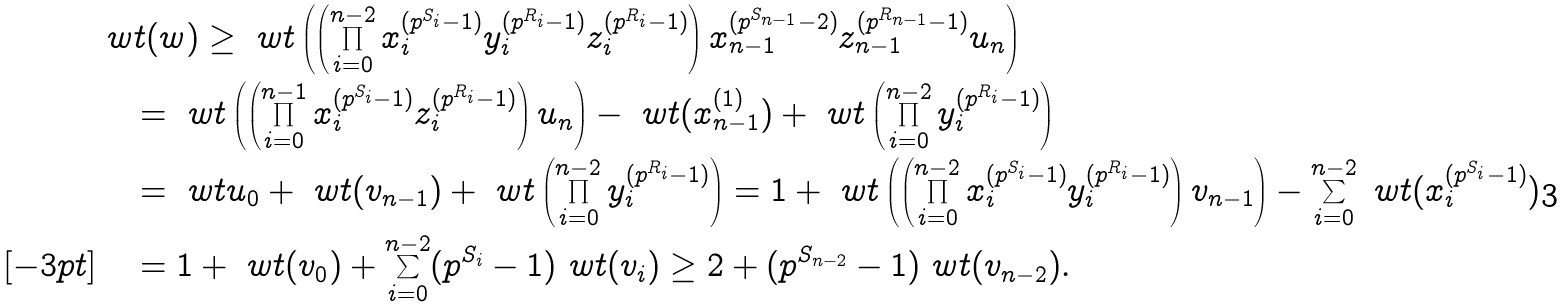Convert formula to latex. <formula><loc_0><loc_0><loc_500><loc_500>& \ w t ( w ) \geq \ w t \left ( \left ( \prod _ { i = 0 } ^ { n - 2 } x _ { i } ^ { ( p ^ { S _ { i } } - 1 ) } y _ { i } ^ { ( p ^ { R _ { i } } - 1 ) } z _ { i } ^ { ( p ^ { R _ { i } } - 1 ) } \right ) x _ { n - 1 } ^ { ( p ^ { S _ { n - 1 } } - 2 ) } z _ { n - 1 } ^ { ( p ^ { R _ { n - 1 } } - 1 ) } u _ { n } \right ) \\ & \quad = \ w t \left ( \left ( \prod _ { i = 0 } ^ { n - 1 } x _ { i } ^ { ( p ^ { S _ { i } } - 1 ) } z _ { i } ^ { ( p ^ { R _ { i } } - 1 ) } \right ) u _ { n } \right ) - \ w t ( x _ { n - 1 } ^ { ( 1 ) } ) + \ w t \left ( \prod _ { i = 0 } ^ { n - 2 } y _ { i } ^ { ( p ^ { R _ { i } } - 1 ) } \right ) \\ & \quad = \ w t u _ { 0 } + \ w t ( v _ { n - 1 } ) + \ w t \left ( \prod _ { i = 0 } ^ { n - 2 } y _ { i } ^ { ( p ^ { R _ { i } } - 1 ) } \right ) = 1 + \ w t \left ( \left ( \prod _ { i = 0 } ^ { n - 2 } x _ { i } ^ { ( p ^ { S _ { i } } - 1 ) } y _ { i } ^ { ( p ^ { R _ { i } } - 1 ) } \right ) v _ { n - 1 } \right ) - \sum _ { i = 0 } ^ { n - 2 } \ w t ( x _ { i } ^ { ( p ^ { S _ { i } } - 1 ) } ) \\ [ - 3 p t ] & \quad = 1 + \ w t ( v _ { 0 } ) + \sum _ { i = 0 } ^ { n - 2 } ( p ^ { S _ { i } } - 1 ) \ w t ( v _ { i } ) \geq 2 + ( p ^ { S _ { n - 2 } } - 1 ) \ w t ( v _ { n - 2 } ) .</formula> 